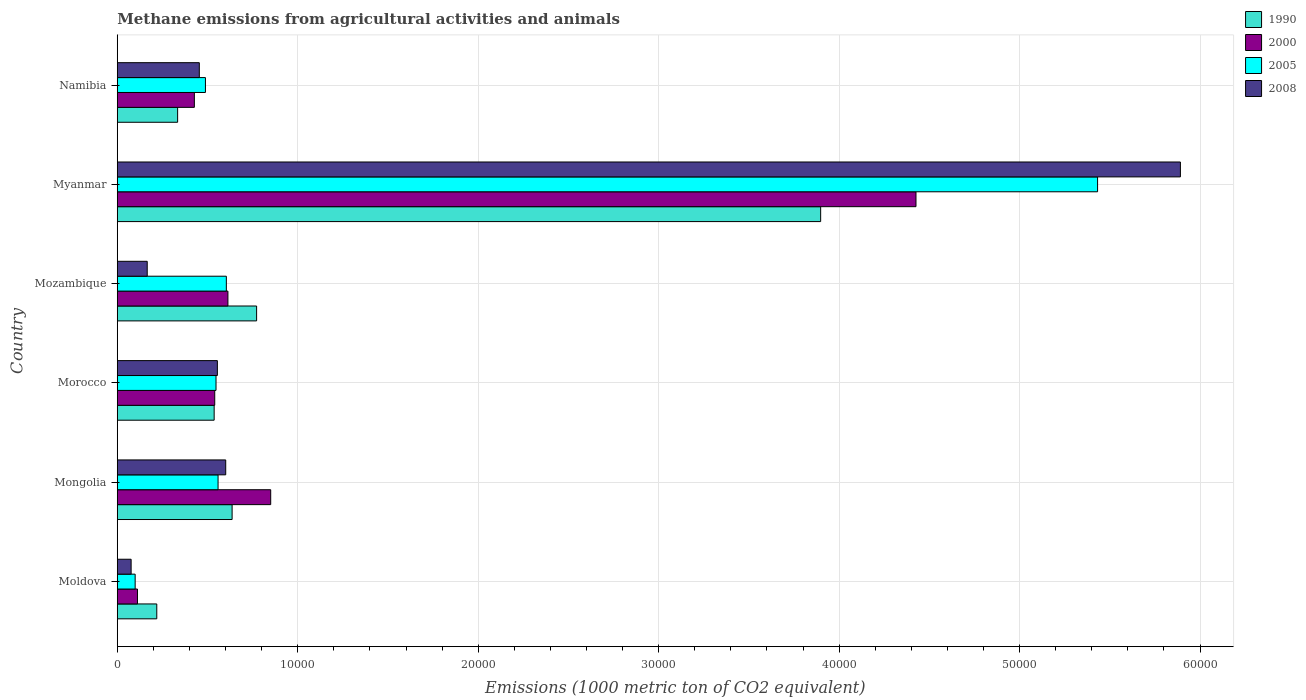How many different coloured bars are there?
Offer a very short reply. 4. How many groups of bars are there?
Offer a terse response. 6. Are the number of bars on each tick of the Y-axis equal?
Your response must be concise. Yes. How many bars are there on the 5th tick from the top?
Keep it short and to the point. 4. How many bars are there on the 5th tick from the bottom?
Ensure brevity in your answer.  4. What is the label of the 4th group of bars from the top?
Your answer should be very brief. Morocco. What is the amount of methane emitted in 2000 in Myanmar?
Your answer should be very brief. 4.43e+04. Across all countries, what is the maximum amount of methane emitted in 2000?
Offer a very short reply. 4.43e+04. Across all countries, what is the minimum amount of methane emitted in 1990?
Provide a short and direct response. 2188.8. In which country was the amount of methane emitted in 1990 maximum?
Your answer should be compact. Myanmar. In which country was the amount of methane emitted in 2000 minimum?
Make the answer very short. Moldova. What is the total amount of methane emitted in 2005 in the graph?
Ensure brevity in your answer.  7.73e+04. What is the difference between the amount of methane emitted in 1990 in Moldova and that in Namibia?
Your answer should be very brief. -1155.3. What is the difference between the amount of methane emitted in 1990 in Moldova and the amount of methane emitted in 2008 in Namibia?
Provide a short and direct response. -2357.1. What is the average amount of methane emitted in 2005 per country?
Give a very brief answer. 1.29e+04. What is the difference between the amount of methane emitted in 2008 and amount of methane emitted in 2005 in Namibia?
Provide a short and direct response. -339.5. What is the ratio of the amount of methane emitted in 2008 in Mongolia to that in Namibia?
Make the answer very short. 1.32. Is the amount of methane emitted in 2008 in Morocco less than that in Mozambique?
Provide a succinct answer. No. Is the difference between the amount of methane emitted in 2008 in Moldova and Namibia greater than the difference between the amount of methane emitted in 2005 in Moldova and Namibia?
Provide a short and direct response. Yes. What is the difference between the highest and the second highest amount of methane emitted in 2000?
Ensure brevity in your answer.  3.58e+04. What is the difference between the highest and the lowest amount of methane emitted in 2005?
Your answer should be compact. 5.33e+04. In how many countries, is the amount of methane emitted in 2005 greater than the average amount of methane emitted in 2005 taken over all countries?
Offer a terse response. 1. Is it the case that in every country, the sum of the amount of methane emitted in 1990 and amount of methane emitted in 2005 is greater than the sum of amount of methane emitted in 2008 and amount of methane emitted in 2000?
Provide a short and direct response. No. What does the 4th bar from the top in Morocco represents?
Make the answer very short. 1990. What does the 3rd bar from the bottom in Morocco represents?
Give a very brief answer. 2005. How many bars are there?
Make the answer very short. 24. Are the values on the major ticks of X-axis written in scientific E-notation?
Your response must be concise. No. Where does the legend appear in the graph?
Provide a succinct answer. Top right. How many legend labels are there?
Offer a terse response. 4. What is the title of the graph?
Offer a very short reply. Methane emissions from agricultural activities and animals. What is the label or title of the X-axis?
Offer a terse response. Emissions (1000 metric ton of CO2 equivalent). What is the label or title of the Y-axis?
Ensure brevity in your answer.  Country. What is the Emissions (1000 metric ton of CO2 equivalent) of 1990 in Moldova?
Provide a succinct answer. 2188.8. What is the Emissions (1000 metric ton of CO2 equivalent) of 2000 in Moldova?
Your response must be concise. 1119.3. What is the Emissions (1000 metric ton of CO2 equivalent) of 2005 in Moldova?
Ensure brevity in your answer.  990.3. What is the Emissions (1000 metric ton of CO2 equivalent) in 2008 in Moldova?
Provide a short and direct response. 767.1. What is the Emissions (1000 metric ton of CO2 equivalent) of 1990 in Mongolia?
Give a very brief answer. 6363.5. What is the Emissions (1000 metric ton of CO2 equivalent) in 2000 in Mongolia?
Give a very brief answer. 8502.3. What is the Emissions (1000 metric ton of CO2 equivalent) in 2005 in Mongolia?
Provide a short and direct response. 5584.9. What is the Emissions (1000 metric ton of CO2 equivalent) of 2008 in Mongolia?
Keep it short and to the point. 6009.3. What is the Emissions (1000 metric ton of CO2 equivalent) in 1990 in Morocco?
Offer a very short reply. 5368.8. What is the Emissions (1000 metric ton of CO2 equivalent) of 2000 in Morocco?
Provide a succinct answer. 5400.3. What is the Emissions (1000 metric ton of CO2 equivalent) of 2005 in Morocco?
Keep it short and to the point. 5471.4. What is the Emissions (1000 metric ton of CO2 equivalent) of 2008 in Morocco?
Provide a succinct answer. 5546.4. What is the Emissions (1000 metric ton of CO2 equivalent) in 1990 in Mozambique?
Offer a very short reply. 7721.4. What is the Emissions (1000 metric ton of CO2 equivalent) of 2000 in Mozambique?
Give a very brief answer. 6130.9. What is the Emissions (1000 metric ton of CO2 equivalent) in 2005 in Mozambique?
Keep it short and to the point. 6043.9. What is the Emissions (1000 metric ton of CO2 equivalent) of 2008 in Mozambique?
Your response must be concise. 1659.3. What is the Emissions (1000 metric ton of CO2 equivalent) in 1990 in Myanmar?
Keep it short and to the point. 3.90e+04. What is the Emissions (1000 metric ton of CO2 equivalent) in 2000 in Myanmar?
Your response must be concise. 4.43e+04. What is the Emissions (1000 metric ton of CO2 equivalent) of 2005 in Myanmar?
Make the answer very short. 5.43e+04. What is the Emissions (1000 metric ton of CO2 equivalent) in 2008 in Myanmar?
Give a very brief answer. 5.89e+04. What is the Emissions (1000 metric ton of CO2 equivalent) of 1990 in Namibia?
Give a very brief answer. 3344.1. What is the Emissions (1000 metric ton of CO2 equivalent) of 2000 in Namibia?
Make the answer very short. 4271.2. What is the Emissions (1000 metric ton of CO2 equivalent) in 2005 in Namibia?
Your response must be concise. 4885.4. What is the Emissions (1000 metric ton of CO2 equivalent) of 2008 in Namibia?
Your answer should be compact. 4545.9. Across all countries, what is the maximum Emissions (1000 metric ton of CO2 equivalent) in 1990?
Keep it short and to the point. 3.90e+04. Across all countries, what is the maximum Emissions (1000 metric ton of CO2 equivalent) of 2000?
Provide a short and direct response. 4.43e+04. Across all countries, what is the maximum Emissions (1000 metric ton of CO2 equivalent) of 2005?
Your response must be concise. 5.43e+04. Across all countries, what is the maximum Emissions (1000 metric ton of CO2 equivalent) in 2008?
Make the answer very short. 5.89e+04. Across all countries, what is the minimum Emissions (1000 metric ton of CO2 equivalent) in 1990?
Keep it short and to the point. 2188.8. Across all countries, what is the minimum Emissions (1000 metric ton of CO2 equivalent) in 2000?
Keep it short and to the point. 1119.3. Across all countries, what is the minimum Emissions (1000 metric ton of CO2 equivalent) of 2005?
Make the answer very short. 990.3. Across all countries, what is the minimum Emissions (1000 metric ton of CO2 equivalent) of 2008?
Your answer should be compact. 767.1. What is the total Emissions (1000 metric ton of CO2 equivalent) in 1990 in the graph?
Give a very brief answer. 6.40e+04. What is the total Emissions (1000 metric ton of CO2 equivalent) of 2000 in the graph?
Your response must be concise. 6.97e+04. What is the total Emissions (1000 metric ton of CO2 equivalent) in 2005 in the graph?
Keep it short and to the point. 7.73e+04. What is the total Emissions (1000 metric ton of CO2 equivalent) in 2008 in the graph?
Offer a very short reply. 7.74e+04. What is the difference between the Emissions (1000 metric ton of CO2 equivalent) of 1990 in Moldova and that in Mongolia?
Your answer should be very brief. -4174.7. What is the difference between the Emissions (1000 metric ton of CO2 equivalent) of 2000 in Moldova and that in Mongolia?
Your response must be concise. -7383. What is the difference between the Emissions (1000 metric ton of CO2 equivalent) in 2005 in Moldova and that in Mongolia?
Give a very brief answer. -4594.6. What is the difference between the Emissions (1000 metric ton of CO2 equivalent) in 2008 in Moldova and that in Mongolia?
Provide a succinct answer. -5242.2. What is the difference between the Emissions (1000 metric ton of CO2 equivalent) in 1990 in Moldova and that in Morocco?
Your answer should be compact. -3180. What is the difference between the Emissions (1000 metric ton of CO2 equivalent) in 2000 in Moldova and that in Morocco?
Keep it short and to the point. -4281. What is the difference between the Emissions (1000 metric ton of CO2 equivalent) of 2005 in Moldova and that in Morocco?
Your answer should be very brief. -4481.1. What is the difference between the Emissions (1000 metric ton of CO2 equivalent) of 2008 in Moldova and that in Morocco?
Give a very brief answer. -4779.3. What is the difference between the Emissions (1000 metric ton of CO2 equivalent) of 1990 in Moldova and that in Mozambique?
Your response must be concise. -5532.6. What is the difference between the Emissions (1000 metric ton of CO2 equivalent) of 2000 in Moldova and that in Mozambique?
Provide a succinct answer. -5011.6. What is the difference between the Emissions (1000 metric ton of CO2 equivalent) of 2005 in Moldova and that in Mozambique?
Ensure brevity in your answer.  -5053.6. What is the difference between the Emissions (1000 metric ton of CO2 equivalent) of 2008 in Moldova and that in Mozambique?
Your answer should be very brief. -892.2. What is the difference between the Emissions (1000 metric ton of CO2 equivalent) of 1990 in Moldova and that in Myanmar?
Your answer should be compact. -3.68e+04. What is the difference between the Emissions (1000 metric ton of CO2 equivalent) in 2000 in Moldova and that in Myanmar?
Make the answer very short. -4.31e+04. What is the difference between the Emissions (1000 metric ton of CO2 equivalent) in 2005 in Moldova and that in Myanmar?
Provide a short and direct response. -5.33e+04. What is the difference between the Emissions (1000 metric ton of CO2 equivalent) of 2008 in Moldova and that in Myanmar?
Offer a very short reply. -5.81e+04. What is the difference between the Emissions (1000 metric ton of CO2 equivalent) of 1990 in Moldova and that in Namibia?
Keep it short and to the point. -1155.3. What is the difference between the Emissions (1000 metric ton of CO2 equivalent) in 2000 in Moldova and that in Namibia?
Your answer should be compact. -3151.9. What is the difference between the Emissions (1000 metric ton of CO2 equivalent) of 2005 in Moldova and that in Namibia?
Ensure brevity in your answer.  -3895.1. What is the difference between the Emissions (1000 metric ton of CO2 equivalent) in 2008 in Moldova and that in Namibia?
Offer a very short reply. -3778.8. What is the difference between the Emissions (1000 metric ton of CO2 equivalent) in 1990 in Mongolia and that in Morocco?
Your answer should be compact. 994.7. What is the difference between the Emissions (1000 metric ton of CO2 equivalent) in 2000 in Mongolia and that in Morocco?
Provide a succinct answer. 3102. What is the difference between the Emissions (1000 metric ton of CO2 equivalent) in 2005 in Mongolia and that in Morocco?
Offer a very short reply. 113.5. What is the difference between the Emissions (1000 metric ton of CO2 equivalent) of 2008 in Mongolia and that in Morocco?
Your response must be concise. 462.9. What is the difference between the Emissions (1000 metric ton of CO2 equivalent) of 1990 in Mongolia and that in Mozambique?
Make the answer very short. -1357.9. What is the difference between the Emissions (1000 metric ton of CO2 equivalent) in 2000 in Mongolia and that in Mozambique?
Your answer should be compact. 2371.4. What is the difference between the Emissions (1000 metric ton of CO2 equivalent) in 2005 in Mongolia and that in Mozambique?
Your answer should be compact. -459. What is the difference between the Emissions (1000 metric ton of CO2 equivalent) of 2008 in Mongolia and that in Mozambique?
Make the answer very short. 4350. What is the difference between the Emissions (1000 metric ton of CO2 equivalent) in 1990 in Mongolia and that in Myanmar?
Make the answer very short. -3.26e+04. What is the difference between the Emissions (1000 metric ton of CO2 equivalent) of 2000 in Mongolia and that in Myanmar?
Provide a succinct answer. -3.58e+04. What is the difference between the Emissions (1000 metric ton of CO2 equivalent) of 2005 in Mongolia and that in Myanmar?
Give a very brief answer. -4.87e+04. What is the difference between the Emissions (1000 metric ton of CO2 equivalent) in 2008 in Mongolia and that in Myanmar?
Give a very brief answer. -5.29e+04. What is the difference between the Emissions (1000 metric ton of CO2 equivalent) of 1990 in Mongolia and that in Namibia?
Provide a short and direct response. 3019.4. What is the difference between the Emissions (1000 metric ton of CO2 equivalent) of 2000 in Mongolia and that in Namibia?
Provide a short and direct response. 4231.1. What is the difference between the Emissions (1000 metric ton of CO2 equivalent) of 2005 in Mongolia and that in Namibia?
Provide a succinct answer. 699.5. What is the difference between the Emissions (1000 metric ton of CO2 equivalent) of 2008 in Mongolia and that in Namibia?
Keep it short and to the point. 1463.4. What is the difference between the Emissions (1000 metric ton of CO2 equivalent) in 1990 in Morocco and that in Mozambique?
Offer a terse response. -2352.6. What is the difference between the Emissions (1000 metric ton of CO2 equivalent) in 2000 in Morocco and that in Mozambique?
Offer a terse response. -730.6. What is the difference between the Emissions (1000 metric ton of CO2 equivalent) in 2005 in Morocco and that in Mozambique?
Offer a terse response. -572.5. What is the difference between the Emissions (1000 metric ton of CO2 equivalent) in 2008 in Morocco and that in Mozambique?
Provide a short and direct response. 3887.1. What is the difference between the Emissions (1000 metric ton of CO2 equivalent) of 1990 in Morocco and that in Myanmar?
Offer a terse response. -3.36e+04. What is the difference between the Emissions (1000 metric ton of CO2 equivalent) in 2000 in Morocco and that in Myanmar?
Provide a short and direct response. -3.89e+04. What is the difference between the Emissions (1000 metric ton of CO2 equivalent) of 2005 in Morocco and that in Myanmar?
Offer a terse response. -4.89e+04. What is the difference between the Emissions (1000 metric ton of CO2 equivalent) in 2008 in Morocco and that in Myanmar?
Make the answer very short. -5.34e+04. What is the difference between the Emissions (1000 metric ton of CO2 equivalent) in 1990 in Morocco and that in Namibia?
Your response must be concise. 2024.7. What is the difference between the Emissions (1000 metric ton of CO2 equivalent) of 2000 in Morocco and that in Namibia?
Give a very brief answer. 1129.1. What is the difference between the Emissions (1000 metric ton of CO2 equivalent) of 2005 in Morocco and that in Namibia?
Provide a succinct answer. 586. What is the difference between the Emissions (1000 metric ton of CO2 equivalent) in 2008 in Morocco and that in Namibia?
Keep it short and to the point. 1000.5. What is the difference between the Emissions (1000 metric ton of CO2 equivalent) of 1990 in Mozambique and that in Myanmar?
Offer a very short reply. -3.13e+04. What is the difference between the Emissions (1000 metric ton of CO2 equivalent) in 2000 in Mozambique and that in Myanmar?
Ensure brevity in your answer.  -3.81e+04. What is the difference between the Emissions (1000 metric ton of CO2 equivalent) in 2005 in Mozambique and that in Myanmar?
Provide a short and direct response. -4.83e+04. What is the difference between the Emissions (1000 metric ton of CO2 equivalent) of 2008 in Mozambique and that in Myanmar?
Offer a terse response. -5.73e+04. What is the difference between the Emissions (1000 metric ton of CO2 equivalent) in 1990 in Mozambique and that in Namibia?
Offer a terse response. 4377.3. What is the difference between the Emissions (1000 metric ton of CO2 equivalent) in 2000 in Mozambique and that in Namibia?
Provide a short and direct response. 1859.7. What is the difference between the Emissions (1000 metric ton of CO2 equivalent) of 2005 in Mozambique and that in Namibia?
Provide a succinct answer. 1158.5. What is the difference between the Emissions (1000 metric ton of CO2 equivalent) of 2008 in Mozambique and that in Namibia?
Offer a very short reply. -2886.6. What is the difference between the Emissions (1000 metric ton of CO2 equivalent) of 1990 in Myanmar and that in Namibia?
Your answer should be compact. 3.56e+04. What is the difference between the Emissions (1000 metric ton of CO2 equivalent) of 2000 in Myanmar and that in Namibia?
Ensure brevity in your answer.  4.00e+04. What is the difference between the Emissions (1000 metric ton of CO2 equivalent) in 2005 in Myanmar and that in Namibia?
Your answer should be compact. 4.94e+04. What is the difference between the Emissions (1000 metric ton of CO2 equivalent) in 2008 in Myanmar and that in Namibia?
Make the answer very short. 5.44e+04. What is the difference between the Emissions (1000 metric ton of CO2 equivalent) in 1990 in Moldova and the Emissions (1000 metric ton of CO2 equivalent) in 2000 in Mongolia?
Give a very brief answer. -6313.5. What is the difference between the Emissions (1000 metric ton of CO2 equivalent) in 1990 in Moldova and the Emissions (1000 metric ton of CO2 equivalent) in 2005 in Mongolia?
Your answer should be compact. -3396.1. What is the difference between the Emissions (1000 metric ton of CO2 equivalent) in 1990 in Moldova and the Emissions (1000 metric ton of CO2 equivalent) in 2008 in Mongolia?
Provide a short and direct response. -3820.5. What is the difference between the Emissions (1000 metric ton of CO2 equivalent) in 2000 in Moldova and the Emissions (1000 metric ton of CO2 equivalent) in 2005 in Mongolia?
Provide a succinct answer. -4465.6. What is the difference between the Emissions (1000 metric ton of CO2 equivalent) of 2000 in Moldova and the Emissions (1000 metric ton of CO2 equivalent) of 2008 in Mongolia?
Provide a succinct answer. -4890. What is the difference between the Emissions (1000 metric ton of CO2 equivalent) in 2005 in Moldova and the Emissions (1000 metric ton of CO2 equivalent) in 2008 in Mongolia?
Provide a short and direct response. -5019. What is the difference between the Emissions (1000 metric ton of CO2 equivalent) of 1990 in Moldova and the Emissions (1000 metric ton of CO2 equivalent) of 2000 in Morocco?
Your response must be concise. -3211.5. What is the difference between the Emissions (1000 metric ton of CO2 equivalent) of 1990 in Moldova and the Emissions (1000 metric ton of CO2 equivalent) of 2005 in Morocco?
Make the answer very short. -3282.6. What is the difference between the Emissions (1000 metric ton of CO2 equivalent) in 1990 in Moldova and the Emissions (1000 metric ton of CO2 equivalent) in 2008 in Morocco?
Provide a succinct answer. -3357.6. What is the difference between the Emissions (1000 metric ton of CO2 equivalent) in 2000 in Moldova and the Emissions (1000 metric ton of CO2 equivalent) in 2005 in Morocco?
Ensure brevity in your answer.  -4352.1. What is the difference between the Emissions (1000 metric ton of CO2 equivalent) of 2000 in Moldova and the Emissions (1000 metric ton of CO2 equivalent) of 2008 in Morocco?
Offer a very short reply. -4427.1. What is the difference between the Emissions (1000 metric ton of CO2 equivalent) in 2005 in Moldova and the Emissions (1000 metric ton of CO2 equivalent) in 2008 in Morocco?
Offer a very short reply. -4556.1. What is the difference between the Emissions (1000 metric ton of CO2 equivalent) in 1990 in Moldova and the Emissions (1000 metric ton of CO2 equivalent) in 2000 in Mozambique?
Ensure brevity in your answer.  -3942.1. What is the difference between the Emissions (1000 metric ton of CO2 equivalent) in 1990 in Moldova and the Emissions (1000 metric ton of CO2 equivalent) in 2005 in Mozambique?
Your response must be concise. -3855.1. What is the difference between the Emissions (1000 metric ton of CO2 equivalent) of 1990 in Moldova and the Emissions (1000 metric ton of CO2 equivalent) of 2008 in Mozambique?
Give a very brief answer. 529.5. What is the difference between the Emissions (1000 metric ton of CO2 equivalent) in 2000 in Moldova and the Emissions (1000 metric ton of CO2 equivalent) in 2005 in Mozambique?
Provide a short and direct response. -4924.6. What is the difference between the Emissions (1000 metric ton of CO2 equivalent) of 2000 in Moldova and the Emissions (1000 metric ton of CO2 equivalent) of 2008 in Mozambique?
Ensure brevity in your answer.  -540. What is the difference between the Emissions (1000 metric ton of CO2 equivalent) of 2005 in Moldova and the Emissions (1000 metric ton of CO2 equivalent) of 2008 in Mozambique?
Provide a succinct answer. -669. What is the difference between the Emissions (1000 metric ton of CO2 equivalent) in 1990 in Moldova and the Emissions (1000 metric ton of CO2 equivalent) in 2000 in Myanmar?
Offer a terse response. -4.21e+04. What is the difference between the Emissions (1000 metric ton of CO2 equivalent) in 1990 in Moldova and the Emissions (1000 metric ton of CO2 equivalent) in 2005 in Myanmar?
Keep it short and to the point. -5.21e+04. What is the difference between the Emissions (1000 metric ton of CO2 equivalent) in 1990 in Moldova and the Emissions (1000 metric ton of CO2 equivalent) in 2008 in Myanmar?
Provide a short and direct response. -5.67e+04. What is the difference between the Emissions (1000 metric ton of CO2 equivalent) in 2000 in Moldova and the Emissions (1000 metric ton of CO2 equivalent) in 2005 in Myanmar?
Offer a very short reply. -5.32e+04. What is the difference between the Emissions (1000 metric ton of CO2 equivalent) in 2000 in Moldova and the Emissions (1000 metric ton of CO2 equivalent) in 2008 in Myanmar?
Offer a very short reply. -5.78e+04. What is the difference between the Emissions (1000 metric ton of CO2 equivalent) in 2005 in Moldova and the Emissions (1000 metric ton of CO2 equivalent) in 2008 in Myanmar?
Offer a very short reply. -5.79e+04. What is the difference between the Emissions (1000 metric ton of CO2 equivalent) in 1990 in Moldova and the Emissions (1000 metric ton of CO2 equivalent) in 2000 in Namibia?
Provide a succinct answer. -2082.4. What is the difference between the Emissions (1000 metric ton of CO2 equivalent) in 1990 in Moldova and the Emissions (1000 metric ton of CO2 equivalent) in 2005 in Namibia?
Keep it short and to the point. -2696.6. What is the difference between the Emissions (1000 metric ton of CO2 equivalent) in 1990 in Moldova and the Emissions (1000 metric ton of CO2 equivalent) in 2008 in Namibia?
Offer a very short reply. -2357.1. What is the difference between the Emissions (1000 metric ton of CO2 equivalent) of 2000 in Moldova and the Emissions (1000 metric ton of CO2 equivalent) of 2005 in Namibia?
Make the answer very short. -3766.1. What is the difference between the Emissions (1000 metric ton of CO2 equivalent) of 2000 in Moldova and the Emissions (1000 metric ton of CO2 equivalent) of 2008 in Namibia?
Provide a succinct answer. -3426.6. What is the difference between the Emissions (1000 metric ton of CO2 equivalent) in 2005 in Moldova and the Emissions (1000 metric ton of CO2 equivalent) in 2008 in Namibia?
Your answer should be very brief. -3555.6. What is the difference between the Emissions (1000 metric ton of CO2 equivalent) of 1990 in Mongolia and the Emissions (1000 metric ton of CO2 equivalent) of 2000 in Morocco?
Offer a very short reply. 963.2. What is the difference between the Emissions (1000 metric ton of CO2 equivalent) of 1990 in Mongolia and the Emissions (1000 metric ton of CO2 equivalent) of 2005 in Morocco?
Give a very brief answer. 892.1. What is the difference between the Emissions (1000 metric ton of CO2 equivalent) in 1990 in Mongolia and the Emissions (1000 metric ton of CO2 equivalent) in 2008 in Morocco?
Offer a very short reply. 817.1. What is the difference between the Emissions (1000 metric ton of CO2 equivalent) of 2000 in Mongolia and the Emissions (1000 metric ton of CO2 equivalent) of 2005 in Morocco?
Provide a short and direct response. 3030.9. What is the difference between the Emissions (1000 metric ton of CO2 equivalent) of 2000 in Mongolia and the Emissions (1000 metric ton of CO2 equivalent) of 2008 in Morocco?
Provide a short and direct response. 2955.9. What is the difference between the Emissions (1000 metric ton of CO2 equivalent) in 2005 in Mongolia and the Emissions (1000 metric ton of CO2 equivalent) in 2008 in Morocco?
Your answer should be very brief. 38.5. What is the difference between the Emissions (1000 metric ton of CO2 equivalent) of 1990 in Mongolia and the Emissions (1000 metric ton of CO2 equivalent) of 2000 in Mozambique?
Provide a succinct answer. 232.6. What is the difference between the Emissions (1000 metric ton of CO2 equivalent) in 1990 in Mongolia and the Emissions (1000 metric ton of CO2 equivalent) in 2005 in Mozambique?
Ensure brevity in your answer.  319.6. What is the difference between the Emissions (1000 metric ton of CO2 equivalent) of 1990 in Mongolia and the Emissions (1000 metric ton of CO2 equivalent) of 2008 in Mozambique?
Your answer should be very brief. 4704.2. What is the difference between the Emissions (1000 metric ton of CO2 equivalent) of 2000 in Mongolia and the Emissions (1000 metric ton of CO2 equivalent) of 2005 in Mozambique?
Offer a very short reply. 2458.4. What is the difference between the Emissions (1000 metric ton of CO2 equivalent) of 2000 in Mongolia and the Emissions (1000 metric ton of CO2 equivalent) of 2008 in Mozambique?
Make the answer very short. 6843. What is the difference between the Emissions (1000 metric ton of CO2 equivalent) in 2005 in Mongolia and the Emissions (1000 metric ton of CO2 equivalent) in 2008 in Mozambique?
Your answer should be compact. 3925.6. What is the difference between the Emissions (1000 metric ton of CO2 equivalent) of 1990 in Mongolia and the Emissions (1000 metric ton of CO2 equivalent) of 2000 in Myanmar?
Your answer should be very brief. -3.79e+04. What is the difference between the Emissions (1000 metric ton of CO2 equivalent) of 1990 in Mongolia and the Emissions (1000 metric ton of CO2 equivalent) of 2005 in Myanmar?
Your answer should be compact. -4.80e+04. What is the difference between the Emissions (1000 metric ton of CO2 equivalent) in 1990 in Mongolia and the Emissions (1000 metric ton of CO2 equivalent) in 2008 in Myanmar?
Give a very brief answer. -5.26e+04. What is the difference between the Emissions (1000 metric ton of CO2 equivalent) of 2000 in Mongolia and the Emissions (1000 metric ton of CO2 equivalent) of 2005 in Myanmar?
Offer a terse response. -4.58e+04. What is the difference between the Emissions (1000 metric ton of CO2 equivalent) of 2000 in Mongolia and the Emissions (1000 metric ton of CO2 equivalent) of 2008 in Myanmar?
Give a very brief answer. -5.04e+04. What is the difference between the Emissions (1000 metric ton of CO2 equivalent) in 2005 in Mongolia and the Emissions (1000 metric ton of CO2 equivalent) in 2008 in Myanmar?
Your answer should be very brief. -5.33e+04. What is the difference between the Emissions (1000 metric ton of CO2 equivalent) in 1990 in Mongolia and the Emissions (1000 metric ton of CO2 equivalent) in 2000 in Namibia?
Offer a very short reply. 2092.3. What is the difference between the Emissions (1000 metric ton of CO2 equivalent) in 1990 in Mongolia and the Emissions (1000 metric ton of CO2 equivalent) in 2005 in Namibia?
Offer a very short reply. 1478.1. What is the difference between the Emissions (1000 metric ton of CO2 equivalent) in 1990 in Mongolia and the Emissions (1000 metric ton of CO2 equivalent) in 2008 in Namibia?
Provide a succinct answer. 1817.6. What is the difference between the Emissions (1000 metric ton of CO2 equivalent) in 2000 in Mongolia and the Emissions (1000 metric ton of CO2 equivalent) in 2005 in Namibia?
Provide a succinct answer. 3616.9. What is the difference between the Emissions (1000 metric ton of CO2 equivalent) in 2000 in Mongolia and the Emissions (1000 metric ton of CO2 equivalent) in 2008 in Namibia?
Your response must be concise. 3956.4. What is the difference between the Emissions (1000 metric ton of CO2 equivalent) in 2005 in Mongolia and the Emissions (1000 metric ton of CO2 equivalent) in 2008 in Namibia?
Ensure brevity in your answer.  1039. What is the difference between the Emissions (1000 metric ton of CO2 equivalent) of 1990 in Morocco and the Emissions (1000 metric ton of CO2 equivalent) of 2000 in Mozambique?
Offer a terse response. -762.1. What is the difference between the Emissions (1000 metric ton of CO2 equivalent) in 1990 in Morocco and the Emissions (1000 metric ton of CO2 equivalent) in 2005 in Mozambique?
Give a very brief answer. -675.1. What is the difference between the Emissions (1000 metric ton of CO2 equivalent) of 1990 in Morocco and the Emissions (1000 metric ton of CO2 equivalent) of 2008 in Mozambique?
Provide a succinct answer. 3709.5. What is the difference between the Emissions (1000 metric ton of CO2 equivalent) of 2000 in Morocco and the Emissions (1000 metric ton of CO2 equivalent) of 2005 in Mozambique?
Keep it short and to the point. -643.6. What is the difference between the Emissions (1000 metric ton of CO2 equivalent) in 2000 in Morocco and the Emissions (1000 metric ton of CO2 equivalent) in 2008 in Mozambique?
Provide a succinct answer. 3741. What is the difference between the Emissions (1000 metric ton of CO2 equivalent) of 2005 in Morocco and the Emissions (1000 metric ton of CO2 equivalent) of 2008 in Mozambique?
Give a very brief answer. 3812.1. What is the difference between the Emissions (1000 metric ton of CO2 equivalent) in 1990 in Morocco and the Emissions (1000 metric ton of CO2 equivalent) in 2000 in Myanmar?
Keep it short and to the point. -3.89e+04. What is the difference between the Emissions (1000 metric ton of CO2 equivalent) in 1990 in Morocco and the Emissions (1000 metric ton of CO2 equivalent) in 2005 in Myanmar?
Keep it short and to the point. -4.90e+04. What is the difference between the Emissions (1000 metric ton of CO2 equivalent) in 1990 in Morocco and the Emissions (1000 metric ton of CO2 equivalent) in 2008 in Myanmar?
Provide a short and direct response. -5.35e+04. What is the difference between the Emissions (1000 metric ton of CO2 equivalent) in 2000 in Morocco and the Emissions (1000 metric ton of CO2 equivalent) in 2005 in Myanmar?
Your answer should be compact. -4.89e+04. What is the difference between the Emissions (1000 metric ton of CO2 equivalent) in 2000 in Morocco and the Emissions (1000 metric ton of CO2 equivalent) in 2008 in Myanmar?
Your answer should be very brief. -5.35e+04. What is the difference between the Emissions (1000 metric ton of CO2 equivalent) in 2005 in Morocco and the Emissions (1000 metric ton of CO2 equivalent) in 2008 in Myanmar?
Keep it short and to the point. -5.34e+04. What is the difference between the Emissions (1000 metric ton of CO2 equivalent) in 1990 in Morocco and the Emissions (1000 metric ton of CO2 equivalent) in 2000 in Namibia?
Make the answer very short. 1097.6. What is the difference between the Emissions (1000 metric ton of CO2 equivalent) of 1990 in Morocco and the Emissions (1000 metric ton of CO2 equivalent) of 2005 in Namibia?
Offer a very short reply. 483.4. What is the difference between the Emissions (1000 metric ton of CO2 equivalent) in 1990 in Morocco and the Emissions (1000 metric ton of CO2 equivalent) in 2008 in Namibia?
Give a very brief answer. 822.9. What is the difference between the Emissions (1000 metric ton of CO2 equivalent) of 2000 in Morocco and the Emissions (1000 metric ton of CO2 equivalent) of 2005 in Namibia?
Your response must be concise. 514.9. What is the difference between the Emissions (1000 metric ton of CO2 equivalent) of 2000 in Morocco and the Emissions (1000 metric ton of CO2 equivalent) of 2008 in Namibia?
Make the answer very short. 854.4. What is the difference between the Emissions (1000 metric ton of CO2 equivalent) in 2005 in Morocco and the Emissions (1000 metric ton of CO2 equivalent) in 2008 in Namibia?
Your answer should be compact. 925.5. What is the difference between the Emissions (1000 metric ton of CO2 equivalent) of 1990 in Mozambique and the Emissions (1000 metric ton of CO2 equivalent) of 2000 in Myanmar?
Make the answer very short. -3.65e+04. What is the difference between the Emissions (1000 metric ton of CO2 equivalent) in 1990 in Mozambique and the Emissions (1000 metric ton of CO2 equivalent) in 2005 in Myanmar?
Provide a short and direct response. -4.66e+04. What is the difference between the Emissions (1000 metric ton of CO2 equivalent) in 1990 in Mozambique and the Emissions (1000 metric ton of CO2 equivalent) in 2008 in Myanmar?
Provide a succinct answer. -5.12e+04. What is the difference between the Emissions (1000 metric ton of CO2 equivalent) in 2000 in Mozambique and the Emissions (1000 metric ton of CO2 equivalent) in 2005 in Myanmar?
Offer a very short reply. -4.82e+04. What is the difference between the Emissions (1000 metric ton of CO2 equivalent) of 2000 in Mozambique and the Emissions (1000 metric ton of CO2 equivalent) of 2008 in Myanmar?
Your answer should be compact. -5.28e+04. What is the difference between the Emissions (1000 metric ton of CO2 equivalent) of 2005 in Mozambique and the Emissions (1000 metric ton of CO2 equivalent) of 2008 in Myanmar?
Keep it short and to the point. -5.29e+04. What is the difference between the Emissions (1000 metric ton of CO2 equivalent) in 1990 in Mozambique and the Emissions (1000 metric ton of CO2 equivalent) in 2000 in Namibia?
Keep it short and to the point. 3450.2. What is the difference between the Emissions (1000 metric ton of CO2 equivalent) of 1990 in Mozambique and the Emissions (1000 metric ton of CO2 equivalent) of 2005 in Namibia?
Your answer should be very brief. 2836. What is the difference between the Emissions (1000 metric ton of CO2 equivalent) in 1990 in Mozambique and the Emissions (1000 metric ton of CO2 equivalent) in 2008 in Namibia?
Make the answer very short. 3175.5. What is the difference between the Emissions (1000 metric ton of CO2 equivalent) of 2000 in Mozambique and the Emissions (1000 metric ton of CO2 equivalent) of 2005 in Namibia?
Keep it short and to the point. 1245.5. What is the difference between the Emissions (1000 metric ton of CO2 equivalent) of 2000 in Mozambique and the Emissions (1000 metric ton of CO2 equivalent) of 2008 in Namibia?
Give a very brief answer. 1585. What is the difference between the Emissions (1000 metric ton of CO2 equivalent) of 2005 in Mozambique and the Emissions (1000 metric ton of CO2 equivalent) of 2008 in Namibia?
Your response must be concise. 1498. What is the difference between the Emissions (1000 metric ton of CO2 equivalent) in 1990 in Myanmar and the Emissions (1000 metric ton of CO2 equivalent) in 2000 in Namibia?
Make the answer very short. 3.47e+04. What is the difference between the Emissions (1000 metric ton of CO2 equivalent) of 1990 in Myanmar and the Emissions (1000 metric ton of CO2 equivalent) of 2005 in Namibia?
Keep it short and to the point. 3.41e+04. What is the difference between the Emissions (1000 metric ton of CO2 equivalent) in 1990 in Myanmar and the Emissions (1000 metric ton of CO2 equivalent) in 2008 in Namibia?
Your answer should be compact. 3.44e+04. What is the difference between the Emissions (1000 metric ton of CO2 equivalent) of 2000 in Myanmar and the Emissions (1000 metric ton of CO2 equivalent) of 2005 in Namibia?
Make the answer very short. 3.94e+04. What is the difference between the Emissions (1000 metric ton of CO2 equivalent) of 2000 in Myanmar and the Emissions (1000 metric ton of CO2 equivalent) of 2008 in Namibia?
Make the answer very short. 3.97e+04. What is the difference between the Emissions (1000 metric ton of CO2 equivalent) of 2005 in Myanmar and the Emissions (1000 metric ton of CO2 equivalent) of 2008 in Namibia?
Keep it short and to the point. 4.98e+04. What is the average Emissions (1000 metric ton of CO2 equivalent) of 1990 per country?
Ensure brevity in your answer.  1.07e+04. What is the average Emissions (1000 metric ton of CO2 equivalent) of 2000 per country?
Offer a terse response. 1.16e+04. What is the average Emissions (1000 metric ton of CO2 equivalent) in 2005 per country?
Your answer should be compact. 1.29e+04. What is the average Emissions (1000 metric ton of CO2 equivalent) of 2008 per country?
Your answer should be very brief. 1.29e+04. What is the difference between the Emissions (1000 metric ton of CO2 equivalent) of 1990 and Emissions (1000 metric ton of CO2 equivalent) of 2000 in Moldova?
Your answer should be very brief. 1069.5. What is the difference between the Emissions (1000 metric ton of CO2 equivalent) of 1990 and Emissions (1000 metric ton of CO2 equivalent) of 2005 in Moldova?
Your response must be concise. 1198.5. What is the difference between the Emissions (1000 metric ton of CO2 equivalent) in 1990 and Emissions (1000 metric ton of CO2 equivalent) in 2008 in Moldova?
Provide a succinct answer. 1421.7. What is the difference between the Emissions (1000 metric ton of CO2 equivalent) of 2000 and Emissions (1000 metric ton of CO2 equivalent) of 2005 in Moldova?
Provide a succinct answer. 129. What is the difference between the Emissions (1000 metric ton of CO2 equivalent) in 2000 and Emissions (1000 metric ton of CO2 equivalent) in 2008 in Moldova?
Offer a terse response. 352.2. What is the difference between the Emissions (1000 metric ton of CO2 equivalent) of 2005 and Emissions (1000 metric ton of CO2 equivalent) of 2008 in Moldova?
Make the answer very short. 223.2. What is the difference between the Emissions (1000 metric ton of CO2 equivalent) of 1990 and Emissions (1000 metric ton of CO2 equivalent) of 2000 in Mongolia?
Provide a succinct answer. -2138.8. What is the difference between the Emissions (1000 metric ton of CO2 equivalent) of 1990 and Emissions (1000 metric ton of CO2 equivalent) of 2005 in Mongolia?
Provide a short and direct response. 778.6. What is the difference between the Emissions (1000 metric ton of CO2 equivalent) of 1990 and Emissions (1000 metric ton of CO2 equivalent) of 2008 in Mongolia?
Your response must be concise. 354.2. What is the difference between the Emissions (1000 metric ton of CO2 equivalent) in 2000 and Emissions (1000 metric ton of CO2 equivalent) in 2005 in Mongolia?
Your answer should be very brief. 2917.4. What is the difference between the Emissions (1000 metric ton of CO2 equivalent) in 2000 and Emissions (1000 metric ton of CO2 equivalent) in 2008 in Mongolia?
Offer a very short reply. 2493. What is the difference between the Emissions (1000 metric ton of CO2 equivalent) in 2005 and Emissions (1000 metric ton of CO2 equivalent) in 2008 in Mongolia?
Your answer should be compact. -424.4. What is the difference between the Emissions (1000 metric ton of CO2 equivalent) in 1990 and Emissions (1000 metric ton of CO2 equivalent) in 2000 in Morocco?
Give a very brief answer. -31.5. What is the difference between the Emissions (1000 metric ton of CO2 equivalent) of 1990 and Emissions (1000 metric ton of CO2 equivalent) of 2005 in Morocco?
Offer a terse response. -102.6. What is the difference between the Emissions (1000 metric ton of CO2 equivalent) of 1990 and Emissions (1000 metric ton of CO2 equivalent) of 2008 in Morocco?
Provide a short and direct response. -177.6. What is the difference between the Emissions (1000 metric ton of CO2 equivalent) in 2000 and Emissions (1000 metric ton of CO2 equivalent) in 2005 in Morocco?
Keep it short and to the point. -71.1. What is the difference between the Emissions (1000 metric ton of CO2 equivalent) in 2000 and Emissions (1000 metric ton of CO2 equivalent) in 2008 in Morocco?
Provide a short and direct response. -146.1. What is the difference between the Emissions (1000 metric ton of CO2 equivalent) of 2005 and Emissions (1000 metric ton of CO2 equivalent) of 2008 in Morocco?
Make the answer very short. -75. What is the difference between the Emissions (1000 metric ton of CO2 equivalent) in 1990 and Emissions (1000 metric ton of CO2 equivalent) in 2000 in Mozambique?
Make the answer very short. 1590.5. What is the difference between the Emissions (1000 metric ton of CO2 equivalent) of 1990 and Emissions (1000 metric ton of CO2 equivalent) of 2005 in Mozambique?
Your answer should be compact. 1677.5. What is the difference between the Emissions (1000 metric ton of CO2 equivalent) in 1990 and Emissions (1000 metric ton of CO2 equivalent) in 2008 in Mozambique?
Offer a terse response. 6062.1. What is the difference between the Emissions (1000 metric ton of CO2 equivalent) in 2000 and Emissions (1000 metric ton of CO2 equivalent) in 2008 in Mozambique?
Make the answer very short. 4471.6. What is the difference between the Emissions (1000 metric ton of CO2 equivalent) of 2005 and Emissions (1000 metric ton of CO2 equivalent) of 2008 in Mozambique?
Make the answer very short. 4384.6. What is the difference between the Emissions (1000 metric ton of CO2 equivalent) of 1990 and Emissions (1000 metric ton of CO2 equivalent) of 2000 in Myanmar?
Offer a terse response. -5282. What is the difference between the Emissions (1000 metric ton of CO2 equivalent) of 1990 and Emissions (1000 metric ton of CO2 equivalent) of 2005 in Myanmar?
Keep it short and to the point. -1.53e+04. What is the difference between the Emissions (1000 metric ton of CO2 equivalent) of 1990 and Emissions (1000 metric ton of CO2 equivalent) of 2008 in Myanmar?
Your answer should be compact. -1.99e+04. What is the difference between the Emissions (1000 metric ton of CO2 equivalent) in 2000 and Emissions (1000 metric ton of CO2 equivalent) in 2005 in Myanmar?
Offer a very short reply. -1.01e+04. What is the difference between the Emissions (1000 metric ton of CO2 equivalent) in 2000 and Emissions (1000 metric ton of CO2 equivalent) in 2008 in Myanmar?
Keep it short and to the point. -1.47e+04. What is the difference between the Emissions (1000 metric ton of CO2 equivalent) in 2005 and Emissions (1000 metric ton of CO2 equivalent) in 2008 in Myanmar?
Offer a very short reply. -4589.9. What is the difference between the Emissions (1000 metric ton of CO2 equivalent) in 1990 and Emissions (1000 metric ton of CO2 equivalent) in 2000 in Namibia?
Ensure brevity in your answer.  -927.1. What is the difference between the Emissions (1000 metric ton of CO2 equivalent) in 1990 and Emissions (1000 metric ton of CO2 equivalent) in 2005 in Namibia?
Offer a very short reply. -1541.3. What is the difference between the Emissions (1000 metric ton of CO2 equivalent) of 1990 and Emissions (1000 metric ton of CO2 equivalent) of 2008 in Namibia?
Your answer should be very brief. -1201.8. What is the difference between the Emissions (1000 metric ton of CO2 equivalent) of 2000 and Emissions (1000 metric ton of CO2 equivalent) of 2005 in Namibia?
Your answer should be compact. -614.2. What is the difference between the Emissions (1000 metric ton of CO2 equivalent) in 2000 and Emissions (1000 metric ton of CO2 equivalent) in 2008 in Namibia?
Offer a very short reply. -274.7. What is the difference between the Emissions (1000 metric ton of CO2 equivalent) in 2005 and Emissions (1000 metric ton of CO2 equivalent) in 2008 in Namibia?
Your answer should be compact. 339.5. What is the ratio of the Emissions (1000 metric ton of CO2 equivalent) in 1990 in Moldova to that in Mongolia?
Offer a very short reply. 0.34. What is the ratio of the Emissions (1000 metric ton of CO2 equivalent) of 2000 in Moldova to that in Mongolia?
Provide a short and direct response. 0.13. What is the ratio of the Emissions (1000 metric ton of CO2 equivalent) in 2005 in Moldova to that in Mongolia?
Offer a terse response. 0.18. What is the ratio of the Emissions (1000 metric ton of CO2 equivalent) in 2008 in Moldova to that in Mongolia?
Your response must be concise. 0.13. What is the ratio of the Emissions (1000 metric ton of CO2 equivalent) in 1990 in Moldova to that in Morocco?
Your answer should be very brief. 0.41. What is the ratio of the Emissions (1000 metric ton of CO2 equivalent) in 2000 in Moldova to that in Morocco?
Your response must be concise. 0.21. What is the ratio of the Emissions (1000 metric ton of CO2 equivalent) of 2005 in Moldova to that in Morocco?
Offer a very short reply. 0.18. What is the ratio of the Emissions (1000 metric ton of CO2 equivalent) of 2008 in Moldova to that in Morocco?
Your response must be concise. 0.14. What is the ratio of the Emissions (1000 metric ton of CO2 equivalent) in 1990 in Moldova to that in Mozambique?
Give a very brief answer. 0.28. What is the ratio of the Emissions (1000 metric ton of CO2 equivalent) in 2000 in Moldova to that in Mozambique?
Your response must be concise. 0.18. What is the ratio of the Emissions (1000 metric ton of CO2 equivalent) of 2005 in Moldova to that in Mozambique?
Provide a short and direct response. 0.16. What is the ratio of the Emissions (1000 metric ton of CO2 equivalent) of 2008 in Moldova to that in Mozambique?
Make the answer very short. 0.46. What is the ratio of the Emissions (1000 metric ton of CO2 equivalent) of 1990 in Moldova to that in Myanmar?
Offer a terse response. 0.06. What is the ratio of the Emissions (1000 metric ton of CO2 equivalent) of 2000 in Moldova to that in Myanmar?
Your answer should be very brief. 0.03. What is the ratio of the Emissions (1000 metric ton of CO2 equivalent) of 2005 in Moldova to that in Myanmar?
Make the answer very short. 0.02. What is the ratio of the Emissions (1000 metric ton of CO2 equivalent) in 2008 in Moldova to that in Myanmar?
Provide a short and direct response. 0.01. What is the ratio of the Emissions (1000 metric ton of CO2 equivalent) in 1990 in Moldova to that in Namibia?
Ensure brevity in your answer.  0.65. What is the ratio of the Emissions (1000 metric ton of CO2 equivalent) of 2000 in Moldova to that in Namibia?
Your answer should be very brief. 0.26. What is the ratio of the Emissions (1000 metric ton of CO2 equivalent) in 2005 in Moldova to that in Namibia?
Provide a succinct answer. 0.2. What is the ratio of the Emissions (1000 metric ton of CO2 equivalent) of 2008 in Moldova to that in Namibia?
Your answer should be very brief. 0.17. What is the ratio of the Emissions (1000 metric ton of CO2 equivalent) in 1990 in Mongolia to that in Morocco?
Provide a succinct answer. 1.19. What is the ratio of the Emissions (1000 metric ton of CO2 equivalent) of 2000 in Mongolia to that in Morocco?
Your answer should be compact. 1.57. What is the ratio of the Emissions (1000 metric ton of CO2 equivalent) in 2005 in Mongolia to that in Morocco?
Your answer should be compact. 1.02. What is the ratio of the Emissions (1000 metric ton of CO2 equivalent) of 2008 in Mongolia to that in Morocco?
Keep it short and to the point. 1.08. What is the ratio of the Emissions (1000 metric ton of CO2 equivalent) of 1990 in Mongolia to that in Mozambique?
Your answer should be very brief. 0.82. What is the ratio of the Emissions (1000 metric ton of CO2 equivalent) in 2000 in Mongolia to that in Mozambique?
Provide a short and direct response. 1.39. What is the ratio of the Emissions (1000 metric ton of CO2 equivalent) in 2005 in Mongolia to that in Mozambique?
Your response must be concise. 0.92. What is the ratio of the Emissions (1000 metric ton of CO2 equivalent) in 2008 in Mongolia to that in Mozambique?
Provide a short and direct response. 3.62. What is the ratio of the Emissions (1000 metric ton of CO2 equivalent) in 1990 in Mongolia to that in Myanmar?
Offer a very short reply. 0.16. What is the ratio of the Emissions (1000 metric ton of CO2 equivalent) in 2000 in Mongolia to that in Myanmar?
Provide a short and direct response. 0.19. What is the ratio of the Emissions (1000 metric ton of CO2 equivalent) of 2005 in Mongolia to that in Myanmar?
Ensure brevity in your answer.  0.1. What is the ratio of the Emissions (1000 metric ton of CO2 equivalent) of 2008 in Mongolia to that in Myanmar?
Ensure brevity in your answer.  0.1. What is the ratio of the Emissions (1000 metric ton of CO2 equivalent) of 1990 in Mongolia to that in Namibia?
Ensure brevity in your answer.  1.9. What is the ratio of the Emissions (1000 metric ton of CO2 equivalent) of 2000 in Mongolia to that in Namibia?
Make the answer very short. 1.99. What is the ratio of the Emissions (1000 metric ton of CO2 equivalent) of 2005 in Mongolia to that in Namibia?
Provide a short and direct response. 1.14. What is the ratio of the Emissions (1000 metric ton of CO2 equivalent) in 2008 in Mongolia to that in Namibia?
Give a very brief answer. 1.32. What is the ratio of the Emissions (1000 metric ton of CO2 equivalent) in 1990 in Morocco to that in Mozambique?
Your answer should be compact. 0.7. What is the ratio of the Emissions (1000 metric ton of CO2 equivalent) of 2000 in Morocco to that in Mozambique?
Your answer should be compact. 0.88. What is the ratio of the Emissions (1000 metric ton of CO2 equivalent) of 2005 in Morocco to that in Mozambique?
Keep it short and to the point. 0.91. What is the ratio of the Emissions (1000 metric ton of CO2 equivalent) in 2008 in Morocco to that in Mozambique?
Keep it short and to the point. 3.34. What is the ratio of the Emissions (1000 metric ton of CO2 equivalent) of 1990 in Morocco to that in Myanmar?
Your answer should be very brief. 0.14. What is the ratio of the Emissions (1000 metric ton of CO2 equivalent) of 2000 in Morocco to that in Myanmar?
Your response must be concise. 0.12. What is the ratio of the Emissions (1000 metric ton of CO2 equivalent) of 2005 in Morocco to that in Myanmar?
Give a very brief answer. 0.1. What is the ratio of the Emissions (1000 metric ton of CO2 equivalent) in 2008 in Morocco to that in Myanmar?
Make the answer very short. 0.09. What is the ratio of the Emissions (1000 metric ton of CO2 equivalent) of 1990 in Morocco to that in Namibia?
Your answer should be very brief. 1.61. What is the ratio of the Emissions (1000 metric ton of CO2 equivalent) of 2000 in Morocco to that in Namibia?
Offer a very short reply. 1.26. What is the ratio of the Emissions (1000 metric ton of CO2 equivalent) in 2005 in Morocco to that in Namibia?
Ensure brevity in your answer.  1.12. What is the ratio of the Emissions (1000 metric ton of CO2 equivalent) in 2008 in Morocco to that in Namibia?
Your answer should be very brief. 1.22. What is the ratio of the Emissions (1000 metric ton of CO2 equivalent) of 1990 in Mozambique to that in Myanmar?
Make the answer very short. 0.2. What is the ratio of the Emissions (1000 metric ton of CO2 equivalent) in 2000 in Mozambique to that in Myanmar?
Offer a very short reply. 0.14. What is the ratio of the Emissions (1000 metric ton of CO2 equivalent) of 2005 in Mozambique to that in Myanmar?
Provide a short and direct response. 0.11. What is the ratio of the Emissions (1000 metric ton of CO2 equivalent) in 2008 in Mozambique to that in Myanmar?
Ensure brevity in your answer.  0.03. What is the ratio of the Emissions (1000 metric ton of CO2 equivalent) in 1990 in Mozambique to that in Namibia?
Make the answer very short. 2.31. What is the ratio of the Emissions (1000 metric ton of CO2 equivalent) of 2000 in Mozambique to that in Namibia?
Keep it short and to the point. 1.44. What is the ratio of the Emissions (1000 metric ton of CO2 equivalent) in 2005 in Mozambique to that in Namibia?
Your response must be concise. 1.24. What is the ratio of the Emissions (1000 metric ton of CO2 equivalent) in 2008 in Mozambique to that in Namibia?
Give a very brief answer. 0.36. What is the ratio of the Emissions (1000 metric ton of CO2 equivalent) of 1990 in Myanmar to that in Namibia?
Ensure brevity in your answer.  11.66. What is the ratio of the Emissions (1000 metric ton of CO2 equivalent) in 2000 in Myanmar to that in Namibia?
Keep it short and to the point. 10.36. What is the ratio of the Emissions (1000 metric ton of CO2 equivalent) in 2005 in Myanmar to that in Namibia?
Ensure brevity in your answer.  11.12. What is the ratio of the Emissions (1000 metric ton of CO2 equivalent) of 2008 in Myanmar to that in Namibia?
Offer a very short reply. 12.96. What is the difference between the highest and the second highest Emissions (1000 metric ton of CO2 equivalent) in 1990?
Offer a terse response. 3.13e+04. What is the difference between the highest and the second highest Emissions (1000 metric ton of CO2 equivalent) of 2000?
Make the answer very short. 3.58e+04. What is the difference between the highest and the second highest Emissions (1000 metric ton of CO2 equivalent) of 2005?
Your response must be concise. 4.83e+04. What is the difference between the highest and the second highest Emissions (1000 metric ton of CO2 equivalent) of 2008?
Offer a terse response. 5.29e+04. What is the difference between the highest and the lowest Emissions (1000 metric ton of CO2 equivalent) of 1990?
Provide a short and direct response. 3.68e+04. What is the difference between the highest and the lowest Emissions (1000 metric ton of CO2 equivalent) in 2000?
Keep it short and to the point. 4.31e+04. What is the difference between the highest and the lowest Emissions (1000 metric ton of CO2 equivalent) of 2005?
Your answer should be very brief. 5.33e+04. What is the difference between the highest and the lowest Emissions (1000 metric ton of CO2 equivalent) in 2008?
Ensure brevity in your answer.  5.81e+04. 